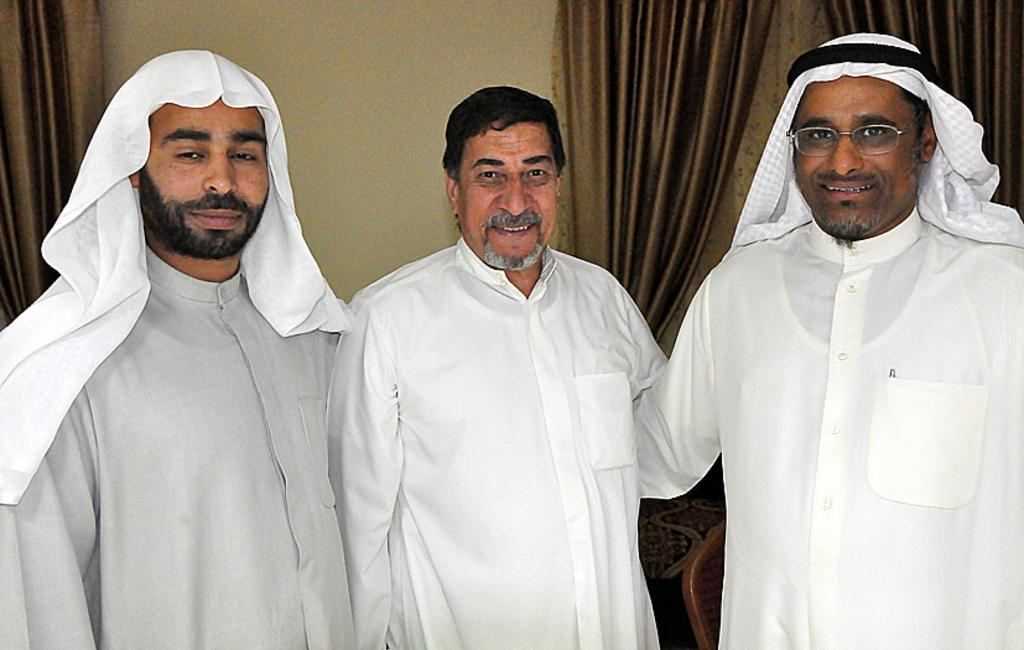How many men are present in the image? There are three men in the image. What are the men wearing? The men are wearing white-colored dresses. Where are the men positioned in the image? The men are standing in the front. What is the facial expression of the men? The men are smiling. What are the men doing? The men are giving a pose to the camera. What can be seen in the background? There is a brown-colored curtain and a wall in the background. What is the manager doing in the image? There is no manager present in the image. 